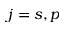<formula> <loc_0><loc_0><loc_500><loc_500>j = s , p</formula> 